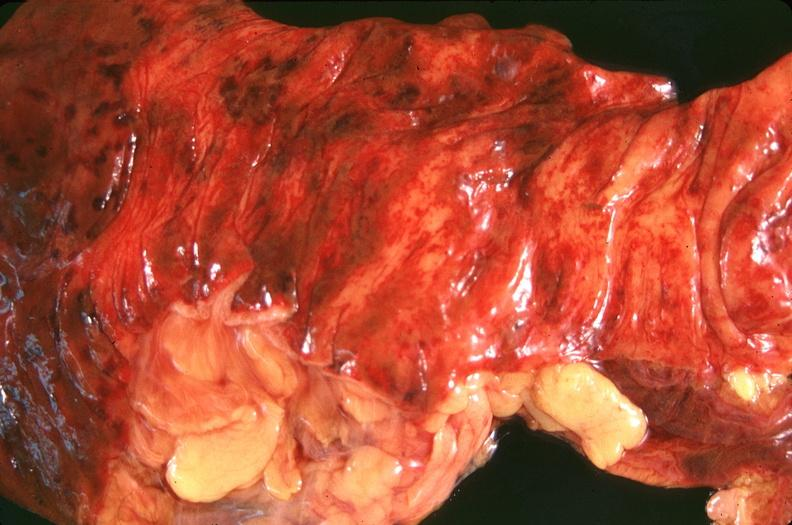s pituitary present?
Answer the question using a single word or phrase. No 